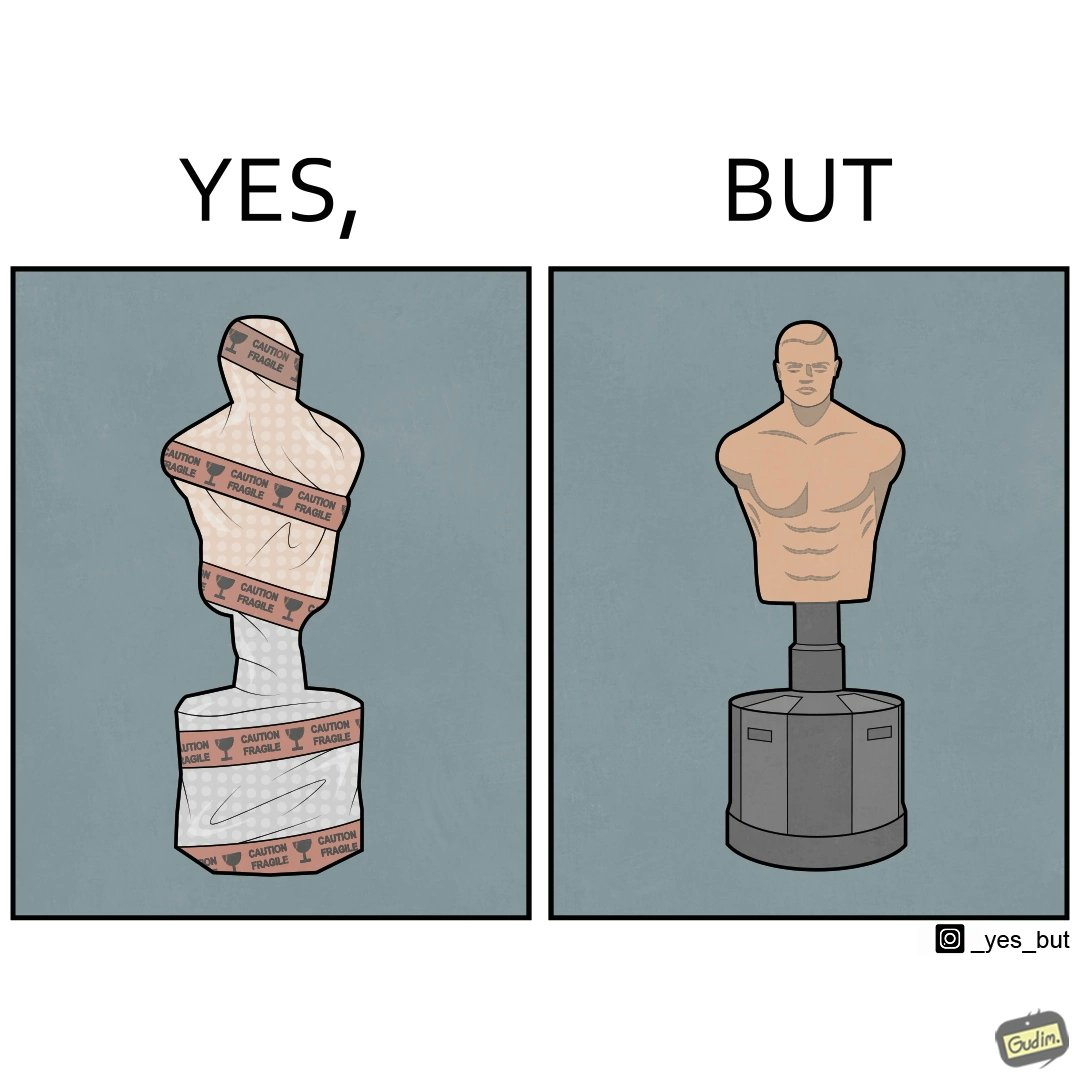Does this image contain satire or humor? Yes, this image is satirical. 